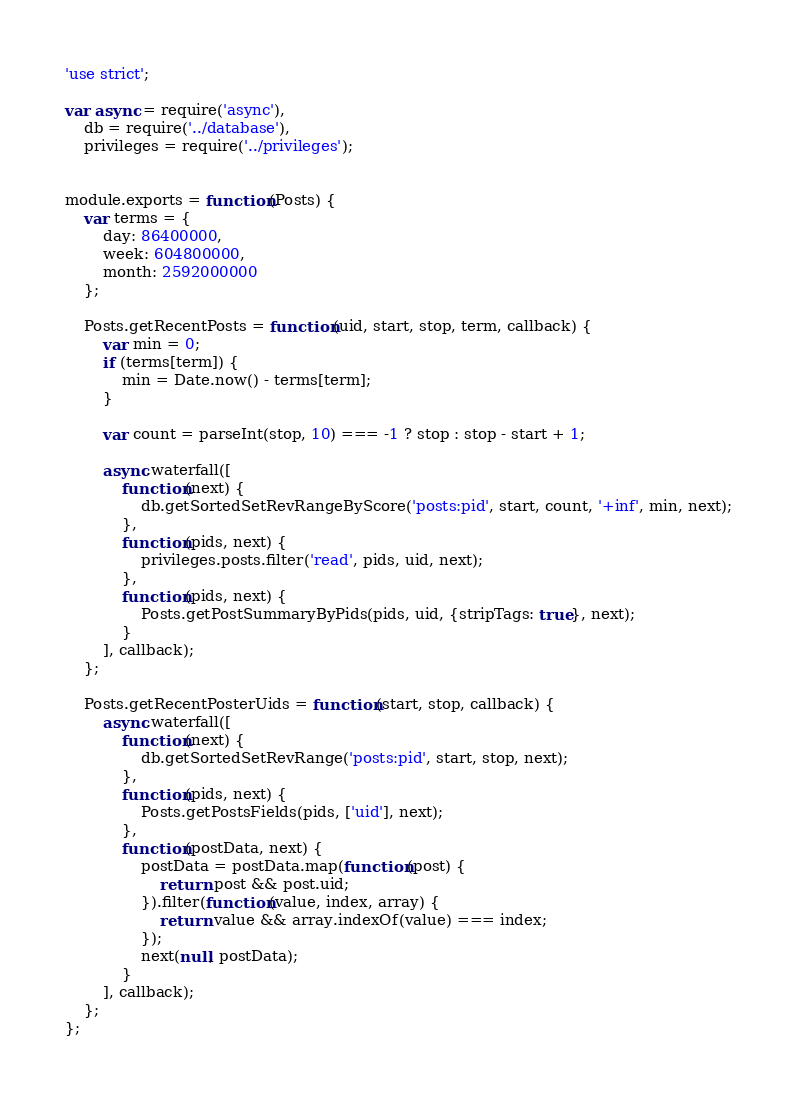<code> <loc_0><loc_0><loc_500><loc_500><_JavaScript_>'use strict';

var async = require('async'),
	db = require('../database'),
	privileges = require('../privileges');


module.exports = function(Posts) {
	var terms = {
		day: 86400000,
		week: 604800000,
		month: 2592000000
	};

	Posts.getRecentPosts = function(uid, start, stop, term, callback) {
		var min = 0;
		if (terms[term]) {
			min = Date.now() - terms[term];
		}

		var count = parseInt(stop, 10) === -1 ? stop : stop - start + 1;

		async.waterfall([
			function(next) {
				db.getSortedSetRevRangeByScore('posts:pid', start, count, '+inf', min, next);
			},
			function(pids, next) {
				privileges.posts.filter('read', pids, uid, next);
			},
			function(pids, next) {
				Posts.getPostSummaryByPids(pids, uid, {stripTags: true}, next);
			}
		], callback);
	};

	Posts.getRecentPosterUids = function(start, stop, callback) {
		async.waterfall([
			function(next) {
				db.getSortedSetRevRange('posts:pid', start, stop, next);
			},
			function(pids, next) {
				Posts.getPostsFields(pids, ['uid'], next);
			},
			function(postData, next) {
				postData = postData.map(function(post) {
					return post && post.uid;
				}).filter(function(value, index, array) {
					return value && array.indexOf(value) === index;
				});
				next(null, postData);
			}
		], callback);
 	};
};
</code> 